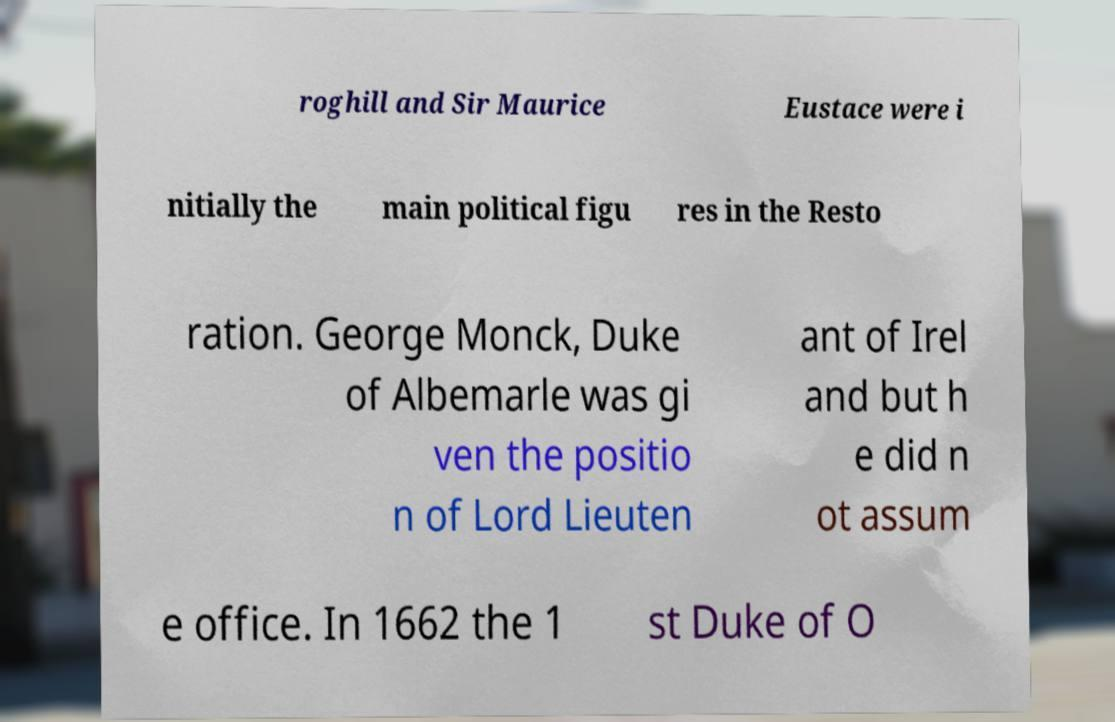There's text embedded in this image that I need extracted. Can you transcribe it verbatim? roghill and Sir Maurice Eustace were i nitially the main political figu res in the Resto ration. George Monck, Duke of Albemarle was gi ven the positio n of Lord Lieuten ant of Irel and but h e did n ot assum e office. In 1662 the 1 st Duke of O 